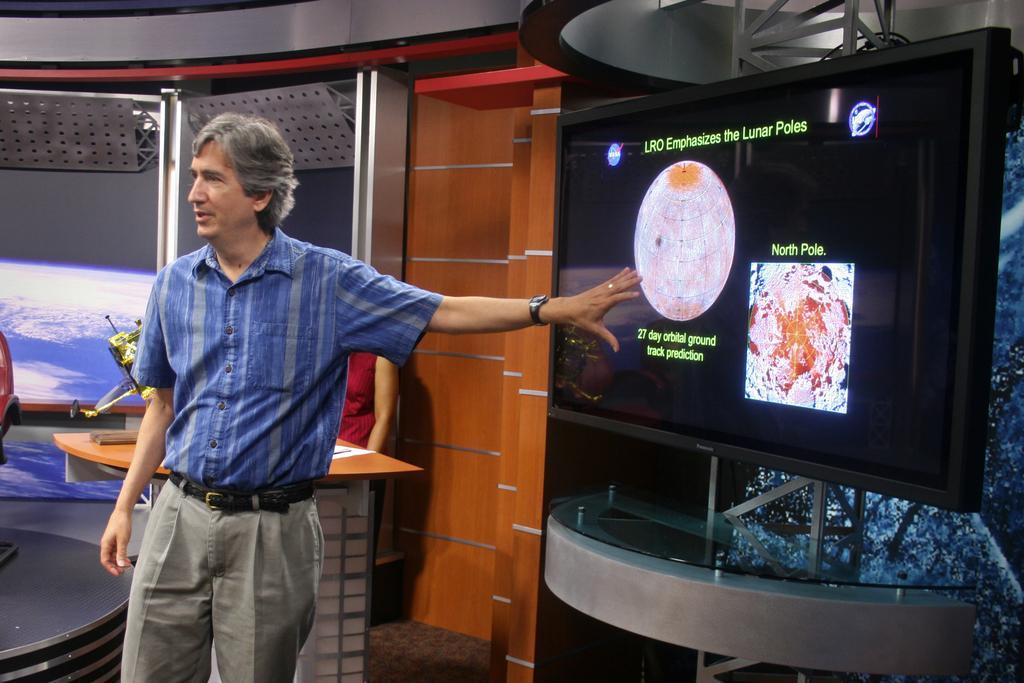Could you give a brief overview of what you see in this image? Man standing near the television ,here there is table and on the table there is paper. 